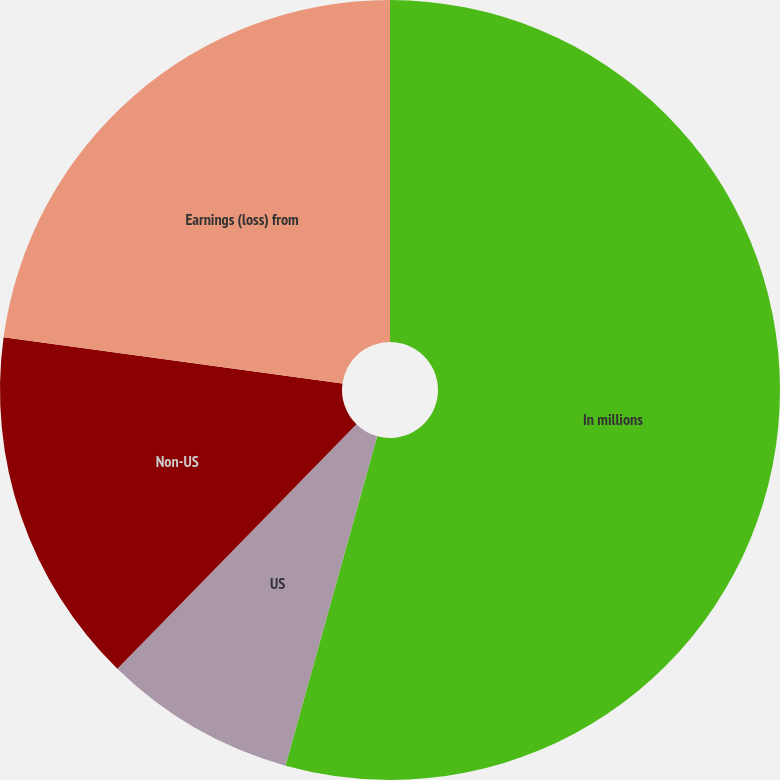Convert chart. <chart><loc_0><loc_0><loc_500><loc_500><pie_chart><fcel>In millions<fcel>US<fcel>Non-US<fcel>Earnings (loss) from<nl><fcel>54.32%<fcel>8.0%<fcel>14.84%<fcel>22.84%<nl></chart> 